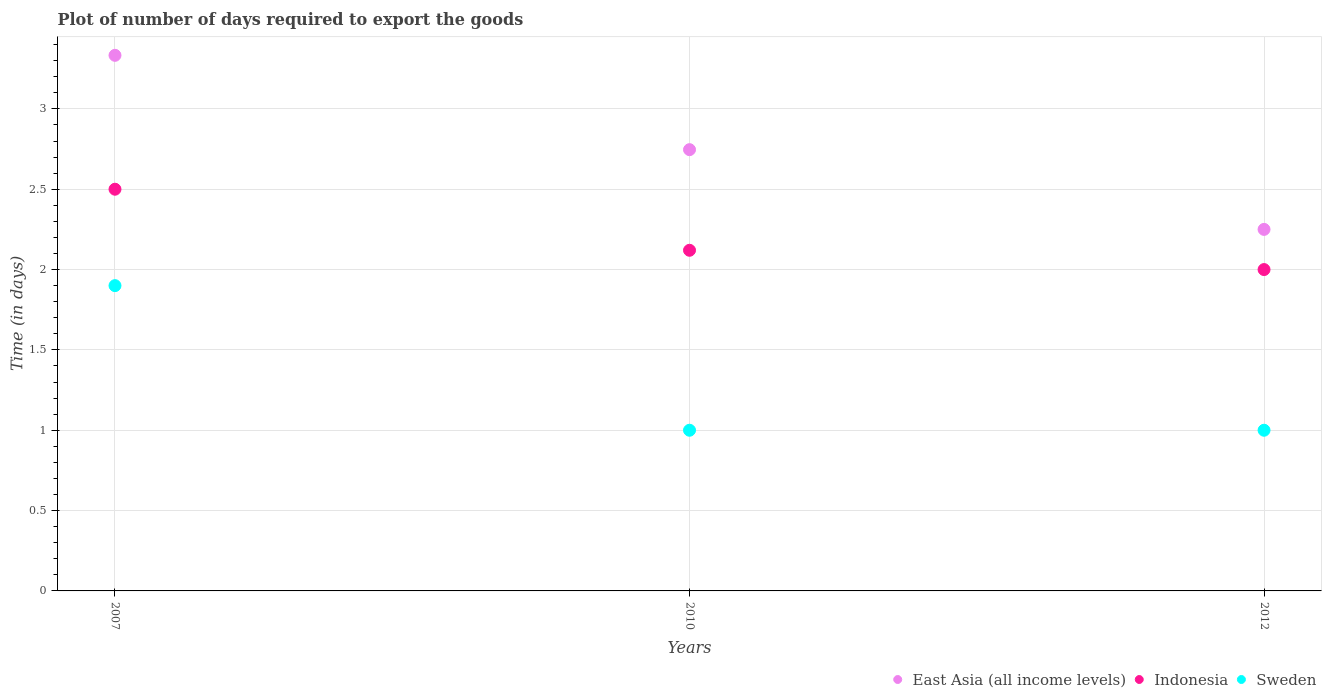How many different coloured dotlines are there?
Provide a succinct answer. 3. Is the number of dotlines equal to the number of legend labels?
Keep it short and to the point. Yes. Across all years, what is the maximum time required to export goods in East Asia (all income levels)?
Your answer should be very brief. 3.33. Across all years, what is the minimum time required to export goods in East Asia (all income levels)?
Give a very brief answer. 2.25. In which year was the time required to export goods in Indonesia minimum?
Your response must be concise. 2012. What is the total time required to export goods in Indonesia in the graph?
Provide a short and direct response. 6.62. What is the difference between the time required to export goods in Sweden in 2007 and that in 2010?
Offer a terse response. 0.9. What is the difference between the time required to export goods in East Asia (all income levels) in 2012 and the time required to export goods in Sweden in 2007?
Ensure brevity in your answer.  0.35. What is the average time required to export goods in Indonesia per year?
Ensure brevity in your answer.  2.21. In the year 2010, what is the difference between the time required to export goods in Indonesia and time required to export goods in Sweden?
Your response must be concise. 1.12. What is the ratio of the time required to export goods in Sweden in 2007 to that in 2012?
Offer a terse response. 1.9. Is the time required to export goods in Sweden in 2007 less than that in 2010?
Your answer should be very brief. No. What is the difference between the highest and the second highest time required to export goods in Sweden?
Keep it short and to the point. 0.9. What is the difference between the highest and the lowest time required to export goods in Indonesia?
Your answer should be compact. 0.5. Is the sum of the time required to export goods in Indonesia in 2007 and 2010 greater than the maximum time required to export goods in Sweden across all years?
Your answer should be compact. Yes. Does the time required to export goods in Indonesia monotonically increase over the years?
Give a very brief answer. No. Is the time required to export goods in Sweden strictly greater than the time required to export goods in Indonesia over the years?
Ensure brevity in your answer.  No. How many dotlines are there?
Provide a succinct answer. 3. What is the difference between two consecutive major ticks on the Y-axis?
Ensure brevity in your answer.  0.5. Does the graph contain any zero values?
Your response must be concise. No. Does the graph contain grids?
Your response must be concise. Yes. Where does the legend appear in the graph?
Your answer should be very brief. Bottom right. What is the title of the graph?
Provide a short and direct response. Plot of number of days required to export the goods. What is the label or title of the X-axis?
Ensure brevity in your answer.  Years. What is the label or title of the Y-axis?
Give a very brief answer. Time (in days). What is the Time (in days) of East Asia (all income levels) in 2007?
Offer a terse response. 3.33. What is the Time (in days) of East Asia (all income levels) in 2010?
Offer a very short reply. 2.75. What is the Time (in days) of Indonesia in 2010?
Provide a succinct answer. 2.12. What is the Time (in days) in East Asia (all income levels) in 2012?
Your answer should be very brief. 2.25. Across all years, what is the maximum Time (in days) of East Asia (all income levels)?
Your answer should be very brief. 3.33. Across all years, what is the minimum Time (in days) in East Asia (all income levels)?
Give a very brief answer. 2.25. What is the total Time (in days) of East Asia (all income levels) in the graph?
Keep it short and to the point. 8.33. What is the total Time (in days) of Indonesia in the graph?
Give a very brief answer. 6.62. What is the difference between the Time (in days) in East Asia (all income levels) in 2007 and that in 2010?
Offer a very short reply. 0.59. What is the difference between the Time (in days) of Indonesia in 2007 and that in 2010?
Your answer should be very brief. 0.38. What is the difference between the Time (in days) in East Asia (all income levels) in 2010 and that in 2012?
Your response must be concise. 0.5. What is the difference between the Time (in days) of Indonesia in 2010 and that in 2012?
Your response must be concise. 0.12. What is the difference between the Time (in days) in Sweden in 2010 and that in 2012?
Offer a terse response. 0. What is the difference between the Time (in days) in East Asia (all income levels) in 2007 and the Time (in days) in Indonesia in 2010?
Provide a short and direct response. 1.21. What is the difference between the Time (in days) of East Asia (all income levels) in 2007 and the Time (in days) of Sweden in 2010?
Your response must be concise. 2.33. What is the difference between the Time (in days) of East Asia (all income levels) in 2007 and the Time (in days) of Indonesia in 2012?
Your answer should be very brief. 1.33. What is the difference between the Time (in days) in East Asia (all income levels) in 2007 and the Time (in days) in Sweden in 2012?
Give a very brief answer. 2.33. What is the difference between the Time (in days) in East Asia (all income levels) in 2010 and the Time (in days) in Indonesia in 2012?
Offer a very short reply. 0.75. What is the difference between the Time (in days) of East Asia (all income levels) in 2010 and the Time (in days) of Sweden in 2012?
Your answer should be very brief. 1.75. What is the difference between the Time (in days) in Indonesia in 2010 and the Time (in days) in Sweden in 2012?
Give a very brief answer. 1.12. What is the average Time (in days) in East Asia (all income levels) per year?
Offer a terse response. 2.78. What is the average Time (in days) in Indonesia per year?
Offer a very short reply. 2.21. What is the average Time (in days) of Sweden per year?
Offer a very short reply. 1.3. In the year 2007, what is the difference between the Time (in days) in East Asia (all income levels) and Time (in days) in Sweden?
Offer a very short reply. 1.43. In the year 2007, what is the difference between the Time (in days) of Indonesia and Time (in days) of Sweden?
Ensure brevity in your answer.  0.6. In the year 2010, what is the difference between the Time (in days) of East Asia (all income levels) and Time (in days) of Indonesia?
Provide a short and direct response. 0.63. In the year 2010, what is the difference between the Time (in days) of East Asia (all income levels) and Time (in days) of Sweden?
Your response must be concise. 1.75. In the year 2010, what is the difference between the Time (in days) in Indonesia and Time (in days) in Sweden?
Provide a succinct answer. 1.12. In the year 2012, what is the difference between the Time (in days) in East Asia (all income levels) and Time (in days) in Sweden?
Provide a succinct answer. 1.25. What is the ratio of the Time (in days) of East Asia (all income levels) in 2007 to that in 2010?
Provide a succinct answer. 1.21. What is the ratio of the Time (in days) of Indonesia in 2007 to that in 2010?
Give a very brief answer. 1.18. What is the ratio of the Time (in days) of East Asia (all income levels) in 2007 to that in 2012?
Provide a short and direct response. 1.48. What is the ratio of the Time (in days) in Indonesia in 2007 to that in 2012?
Your response must be concise. 1.25. What is the ratio of the Time (in days) of East Asia (all income levels) in 2010 to that in 2012?
Offer a terse response. 1.22. What is the ratio of the Time (in days) in Indonesia in 2010 to that in 2012?
Make the answer very short. 1.06. What is the difference between the highest and the second highest Time (in days) in East Asia (all income levels)?
Provide a short and direct response. 0.59. What is the difference between the highest and the second highest Time (in days) in Indonesia?
Make the answer very short. 0.38. What is the difference between the highest and the second highest Time (in days) in Sweden?
Keep it short and to the point. 0.9. What is the difference between the highest and the lowest Time (in days) of East Asia (all income levels)?
Provide a succinct answer. 1.08. What is the difference between the highest and the lowest Time (in days) of Sweden?
Your response must be concise. 0.9. 